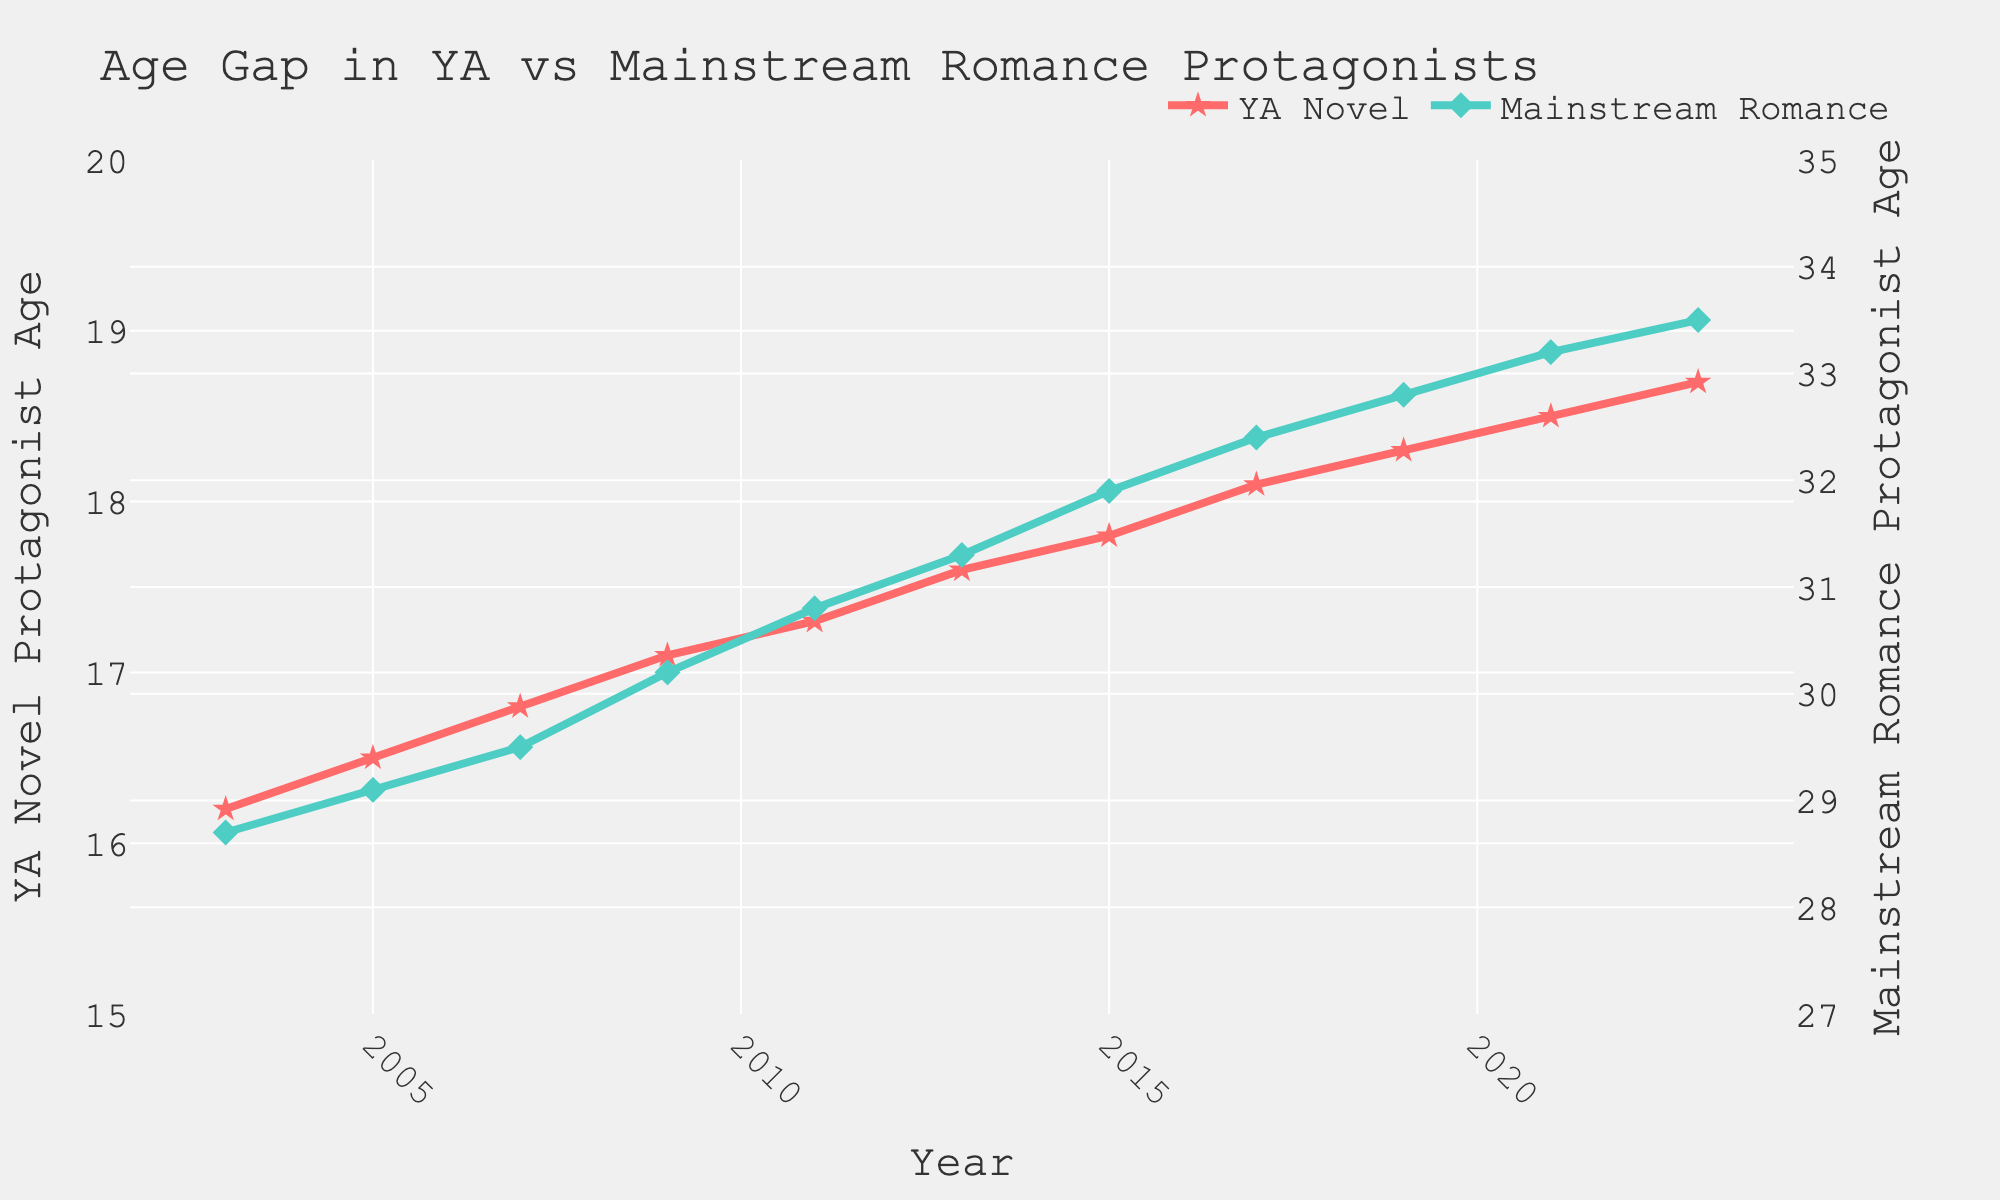What is the overall trend in the age of YA novel protagonists over the last 20 years? From 2003 to 2023, the age of YA novel protagonists shows a gradual increase. The average age rises from 16.2 years in 2003 to 18.7 years in 2023, indicating a trend of older protagonists in YA novels over time.
Answer: Increasing How does the age of mainstream romance protagonists in 2023 compare to their age in 2003? The age of mainstream romance protagonists increases from 28.7 years in 2003 to 33.5 years in 2023. This shows a noticeable increase of 4.8 years over the 20-year span.
Answer: Higher What age difference between YA novel protagonists and mainstream romance protagonists appears most consistent across the years? The age difference between YA novel protagonists and mainstream romance protagonists consistently increases each year. Starting at an age difference of 12.5 years in 2003 to 14.8 years in 2023, showing that the age gap is widening over time.
Answer: Widening In which two years did the YA novel protagonists and mainstream romance protagonists have the closest age difference? The closest age difference occurred in 2003 and 2005. In 2003, the difference was 12.5 years, and in 2005, it was 12.6 years. This difference is relatively less compared to other years.
Answer: 2003 and 2005 How do the visual attributes of the lines for YA novels and mainstream romance novels differ? The line for YA novels is red with star markers, and it is situated lower on the graph, representing younger ages. In contrast, the mainstream romance line is green with diamond markers and positioned higher, representing older ages.
Answer: Red stars and green diamonds During which period do YA novels show the steepest increase in protagonist age? Between 2007 and 2009, there is a noticeable steeper rise in the age of YA novel protagonists, from 16.8 to 17.1, indicating a rapid change relative to previous years.
Answer: 2007-2009 What is the average age of YA novel protagonists in 2015 and 2017? To find the average, add the ages for the two years and divide by 2: (17.8 + 18.1) / 2 = 17.95 years.
Answer: 17.95 How much older are mainstream romance protagonists on average in 2023 compared to YA novel protagonists? In 2023, the average age of mainstream romance protagonists is 33.5 years, while for YA novel protagonists, it is 18.7 years. The difference is calculated by subtracting these values: 33.5 - 18.7 = 14.8 years.
Answer: 14.8 years Which year did mainstream romance protagonists see the fastest rise in age, and what was the age increment? Between 2007 and 2009, mainstream romance protagonists saw the fastest rise, increasing from 29.5 to 30.2. The increment is 30.2 - 29.5 = 0.7 years.
Answer: 2007-2009, 0.7 years 